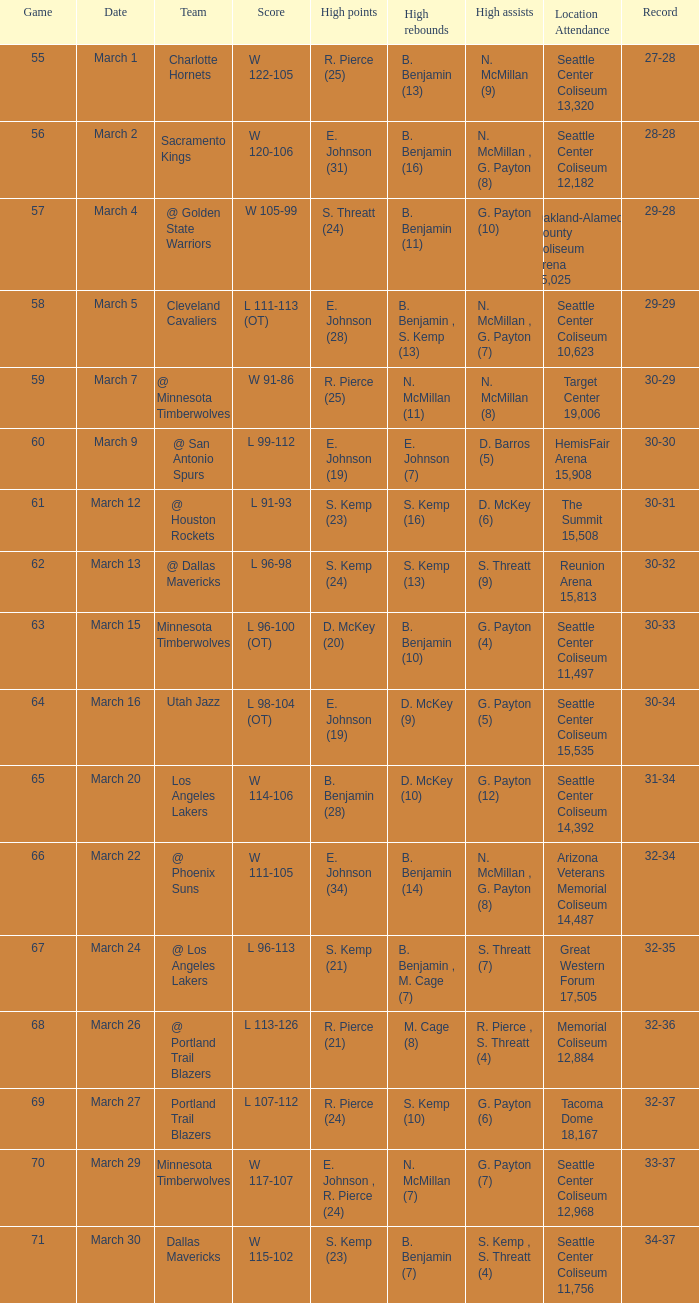Which Game has High assists of s. threatt (9)? 62.0. Would you be able to parse every entry in this table? {'header': ['Game', 'Date', 'Team', 'Score', 'High points', 'High rebounds', 'High assists', 'Location Attendance', 'Record'], 'rows': [['55', 'March 1', 'Charlotte Hornets', 'W 122-105', 'R. Pierce (25)', 'B. Benjamin (13)', 'N. McMillan (9)', 'Seattle Center Coliseum 13,320', '27-28'], ['56', 'March 2', 'Sacramento Kings', 'W 120-106', 'E. Johnson (31)', 'B. Benjamin (16)', 'N. McMillan , G. Payton (8)', 'Seattle Center Coliseum 12,182', '28-28'], ['57', 'March 4', '@ Golden State Warriors', 'W 105-99', 'S. Threatt (24)', 'B. Benjamin (11)', 'G. Payton (10)', 'Oakland-Alameda County Coliseum Arena 15,025', '29-28'], ['58', 'March 5', 'Cleveland Cavaliers', 'L 111-113 (OT)', 'E. Johnson (28)', 'B. Benjamin , S. Kemp (13)', 'N. McMillan , G. Payton (7)', 'Seattle Center Coliseum 10,623', '29-29'], ['59', 'March 7', '@ Minnesota Timberwolves', 'W 91-86', 'R. Pierce (25)', 'N. McMillan (11)', 'N. McMillan (8)', 'Target Center 19,006', '30-29'], ['60', 'March 9', '@ San Antonio Spurs', 'L 99-112', 'E. Johnson (19)', 'E. Johnson (7)', 'D. Barros (5)', 'HemisFair Arena 15,908', '30-30'], ['61', 'March 12', '@ Houston Rockets', 'L 91-93', 'S. Kemp (23)', 'S. Kemp (16)', 'D. McKey (6)', 'The Summit 15,508', '30-31'], ['62', 'March 13', '@ Dallas Mavericks', 'L 96-98', 'S. Kemp (24)', 'S. Kemp (13)', 'S. Threatt (9)', 'Reunion Arena 15,813', '30-32'], ['63', 'March 15', 'Minnesota Timberwolves', 'L 96-100 (OT)', 'D. McKey (20)', 'B. Benjamin (10)', 'G. Payton (4)', 'Seattle Center Coliseum 11,497', '30-33'], ['64', 'March 16', 'Utah Jazz', 'L 98-104 (OT)', 'E. Johnson (19)', 'D. McKey (9)', 'G. Payton (5)', 'Seattle Center Coliseum 15,535', '30-34'], ['65', 'March 20', 'Los Angeles Lakers', 'W 114-106', 'B. Benjamin (28)', 'D. McKey (10)', 'G. Payton (12)', 'Seattle Center Coliseum 14,392', '31-34'], ['66', 'March 22', '@ Phoenix Suns', 'W 111-105', 'E. Johnson (34)', 'B. Benjamin (14)', 'N. McMillan , G. Payton (8)', 'Arizona Veterans Memorial Coliseum 14,487', '32-34'], ['67', 'March 24', '@ Los Angeles Lakers', 'L 96-113', 'S. Kemp (21)', 'B. Benjamin , M. Cage (7)', 'S. Threatt (7)', 'Great Western Forum 17,505', '32-35'], ['68', 'March 26', '@ Portland Trail Blazers', 'L 113-126', 'R. Pierce (21)', 'M. Cage (8)', 'R. Pierce , S. Threatt (4)', 'Memorial Coliseum 12,884', '32-36'], ['69', 'March 27', 'Portland Trail Blazers', 'L 107-112', 'R. Pierce (24)', 'S. Kemp (10)', 'G. Payton (6)', 'Tacoma Dome 18,167', '32-37'], ['70', 'March 29', 'Minnesota Timberwolves', 'W 117-107', 'E. Johnson , R. Pierce (24)', 'N. McMillan (7)', 'G. Payton (7)', 'Seattle Center Coliseum 12,968', '33-37'], ['71', 'March 30', 'Dallas Mavericks', 'W 115-102', 'S. Kemp (23)', 'B. Benjamin (7)', 'S. Kemp , S. Threatt (4)', 'Seattle Center Coliseum 11,756', '34-37']]} 